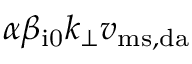<formula> <loc_0><loc_0><loc_500><loc_500>\alpha \beta _ { i 0 } k _ { \perp } v _ { m s , d a }</formula> 